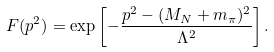<formula> <loc_0><loc_0><loc_500><loc_500>F ( p ^ { 2 } ) = \exp \left [ - \frac { p ^ { 2 } - ( M _ { N } + m _ { \pi } ) ^ { 2 } } { \Lambda ^ { 2 } } \right ] .</formula> 